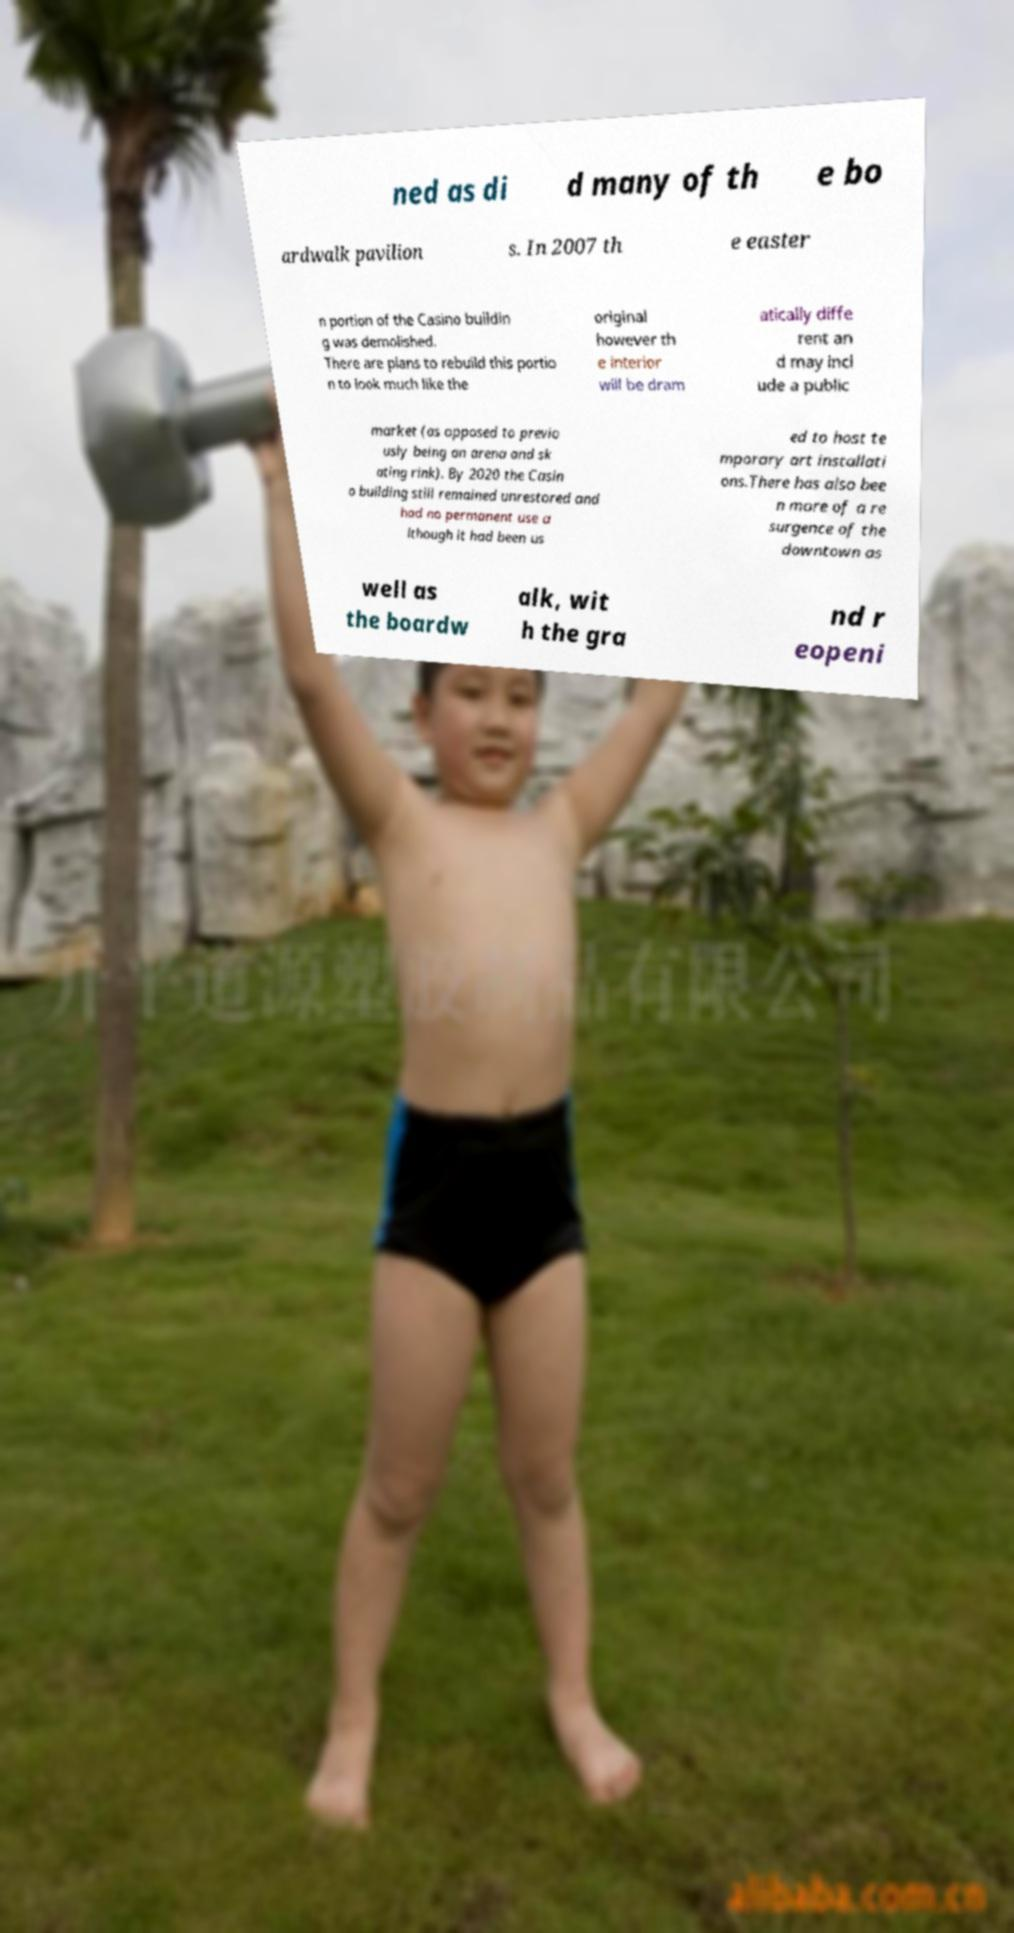Please read and relay the text visible in this image. What does it say? ned as di d many of th e bo ardwalk pavilion s. In 2007 th e easter n portion of the Casino buildin g was demolished. There are plans to rebuild this portio n to look much like the original however th e interior will be dram atically diffe rent an d may incl ude a public market (as opposed to previo usly being an arena and sk ating rink). By 2020 the Casin o building still remained unrestored and had no permanent use a lthough it had been us ed to host te mporary art installati ons.There has also bee n more of a re surgence of the downtown as well as the boardw alk, wit h the gra nd r eopeni 